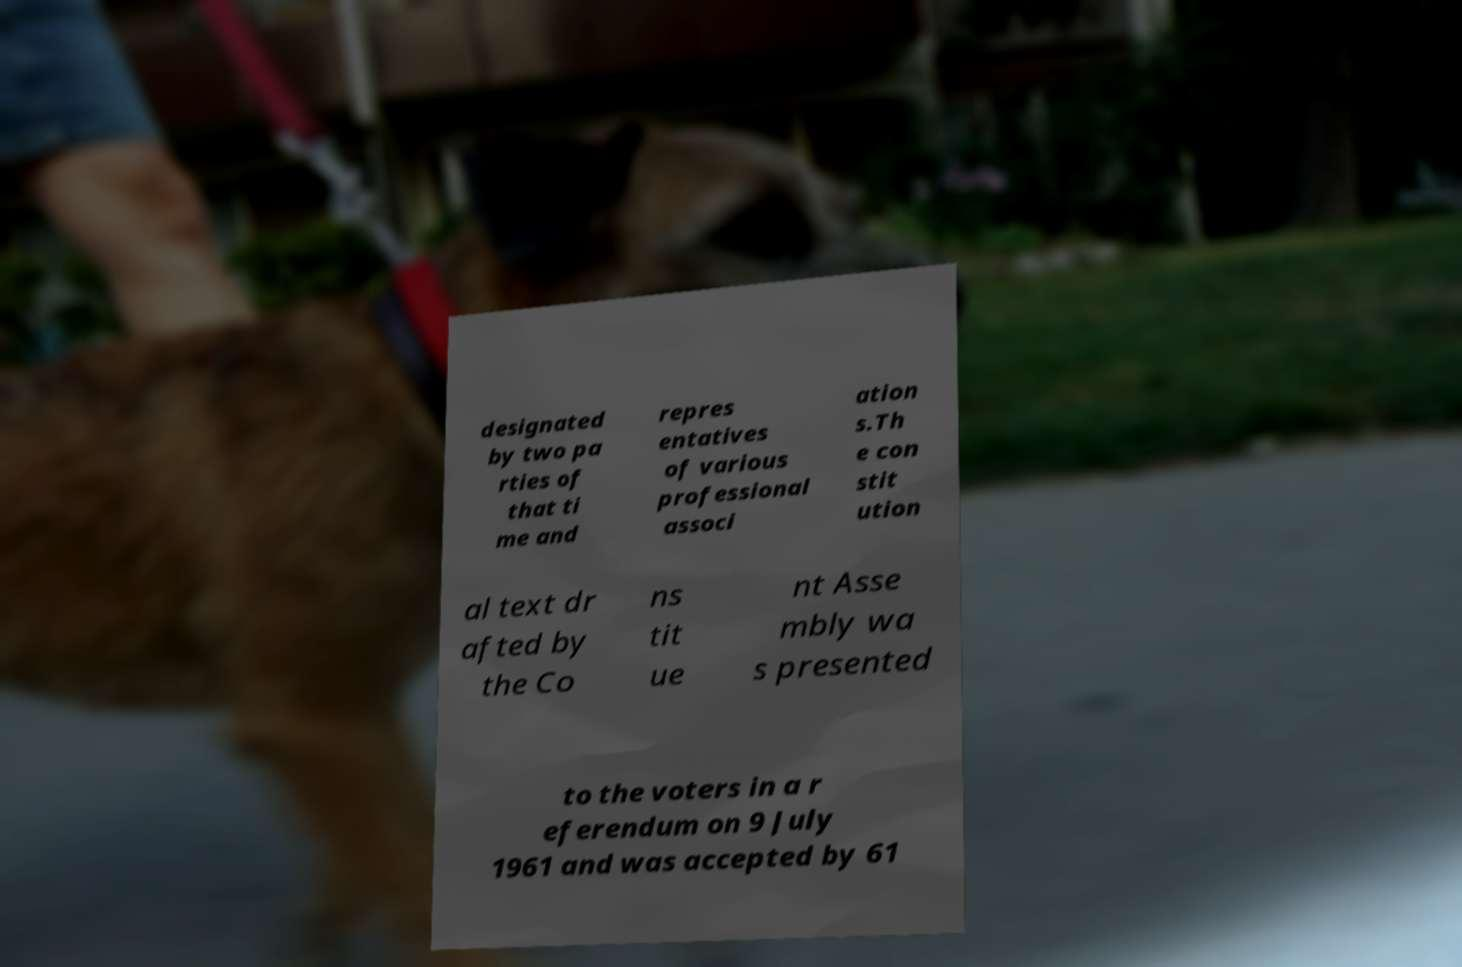Could you extract and type out the text from this image? designated by two pa rties of that ti me and repres entatives of various professional associ ation s.Th e con stit ution al text dr afted by the Co ns tit ue nt Asse mbly wa s presented to the voters in a r eferendum on 9 July 1961 and was accepted by 61 